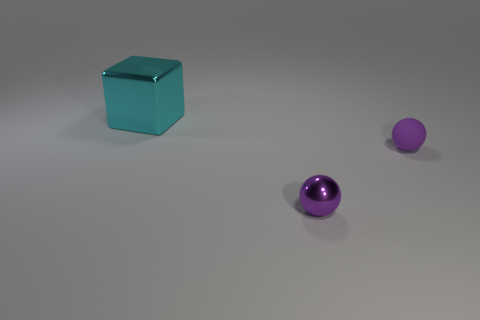Add 1 large rubber cylinders. How many objects exist? 4 Subtract all cubes. How many objects are left? 2 Add 2 purple metal balls. How many purple metal balls are left? 3 Add 1 large blue rubber cubes. How many large blue rubber cubes exist? 1 Subtract 1 cyan blocks. How many objects are left? 2 Subtract all tiny red rubber cylinders. Subtract all balls. How many objects are left? 1 